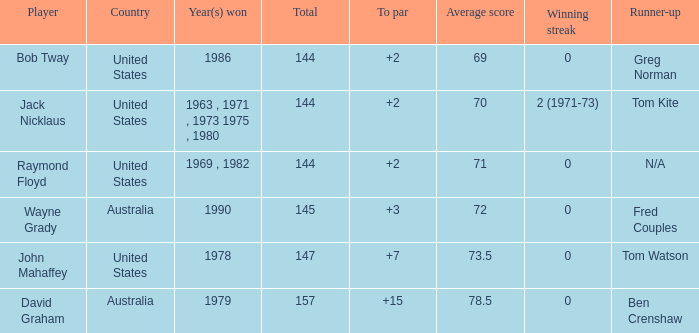What was the average round score of the player who won in 1978? 147.0. 